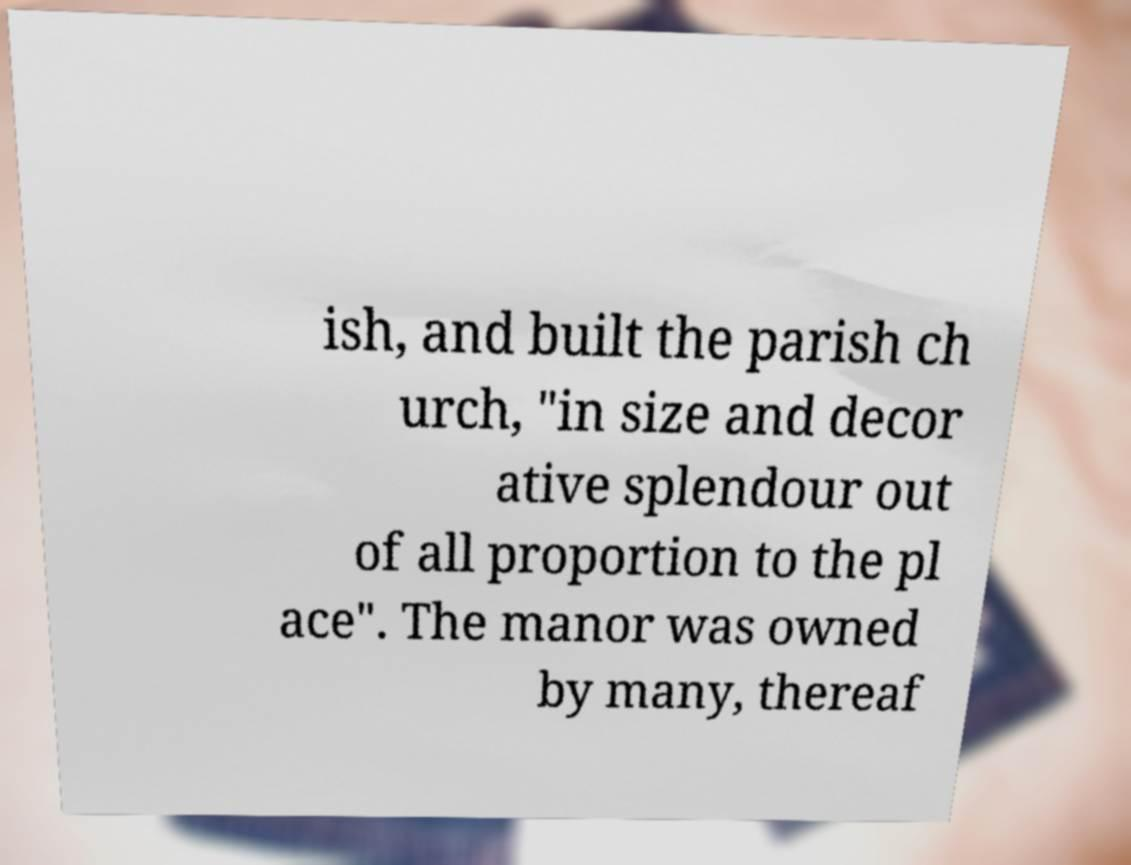What messages or text are displayed in this image? I need them in a readable, typed format. ish, and built the parish ch urch, "in size and decor ative splendour out of all proportion to the pl ace". The manor was owned by many, thereaf 